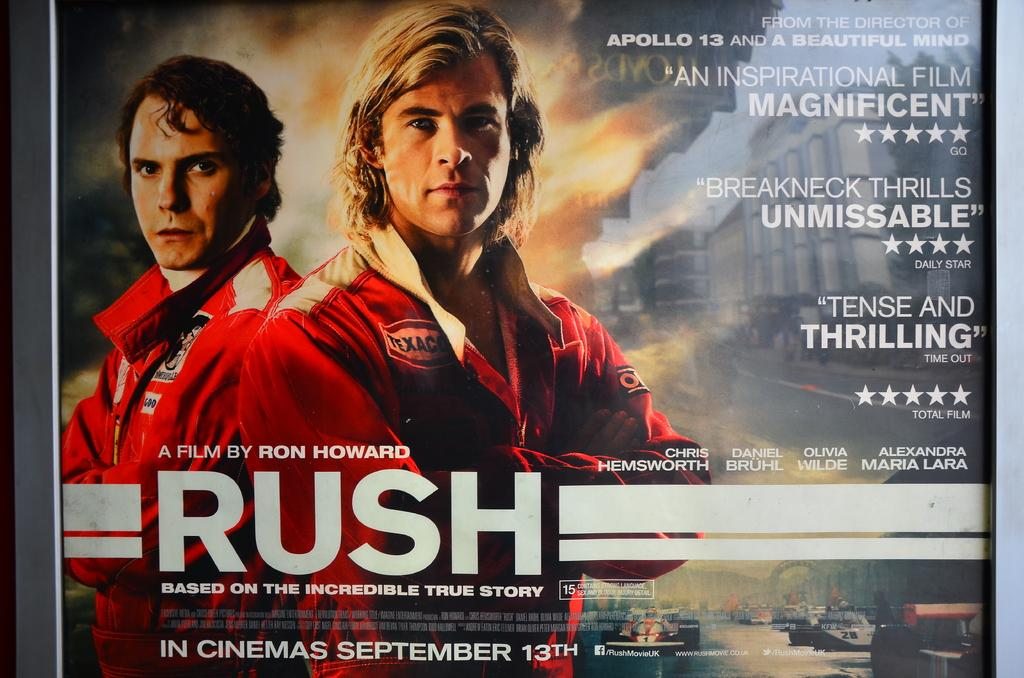<image>
Relay a brief, clear account of the picture shown. An advertisement for the movie Rush, a film by Ron Howard describes the move as "Tense and Thrilling". 